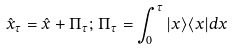<formula> <loc_0><loc_0><loc_500><loc_500>\hat { x } _ { \tau } = \hat { x } + \Pi _ { \tau } ; \, \Pi _ { \tau } = \int _ { 0 } ^ { \tau } | x \rangle \langle x | d x</formula> 